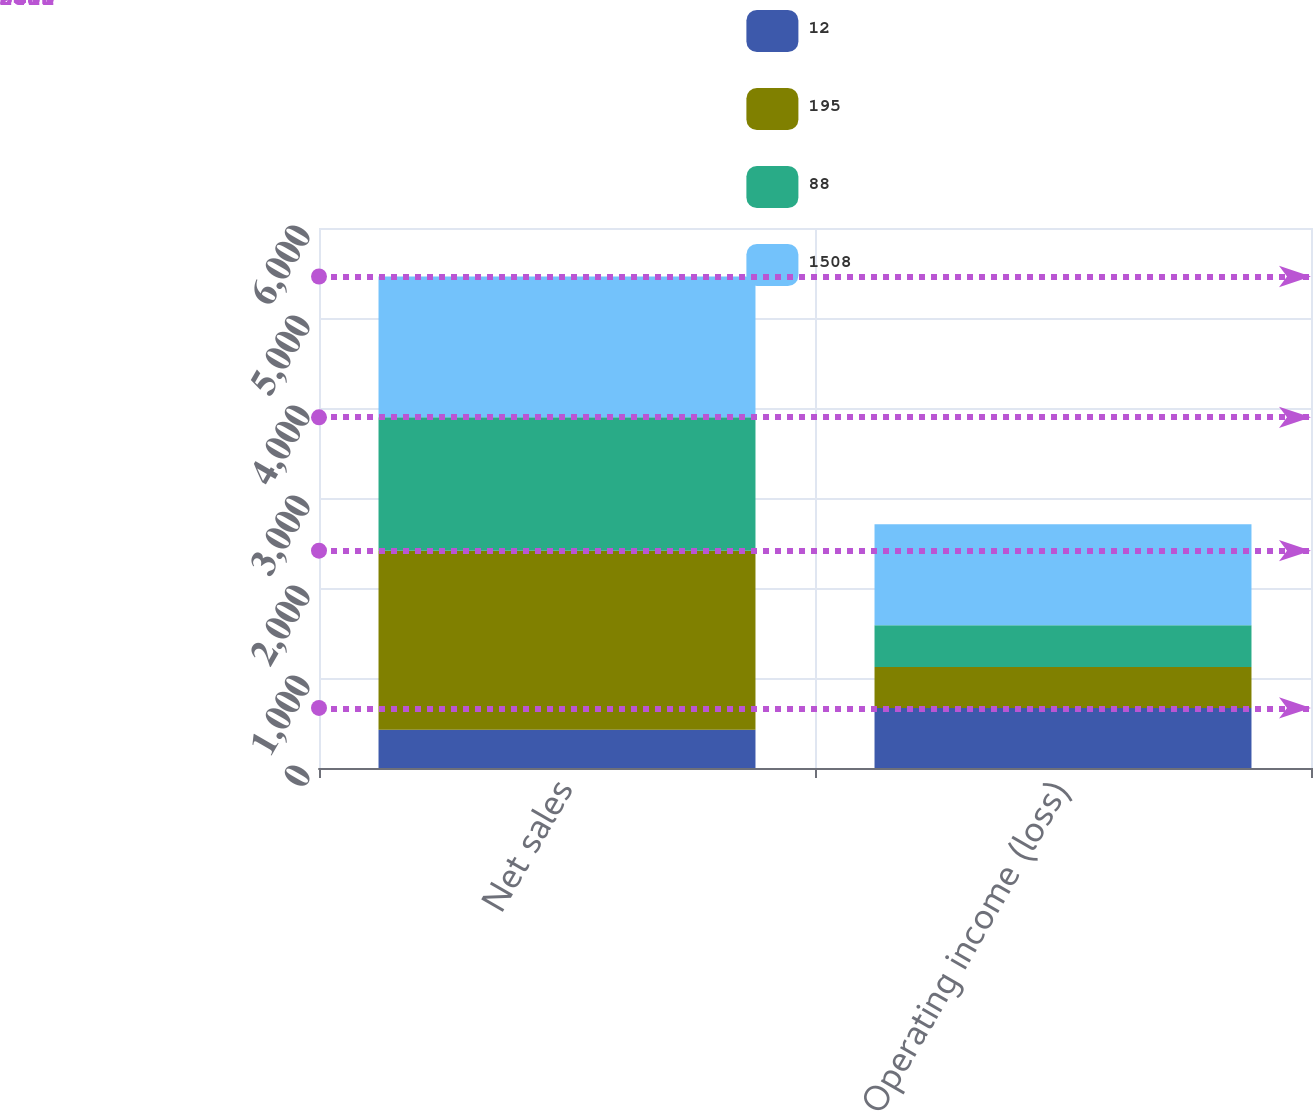Convert chart to OTSL. <chart><loc_0><loc_0><loc_500><loc_500><stacked_bar_chart><ecel><fcel>Net sales<fcel>Operating income (loss)<nl><fcel>12<fcel>425<fcel>668<nl><fcel>195<fcel>1990<fcel>453<nl><fcel>88<fcel>1481<fcel>466<nl><fcel>1508<fcel>1565<fcel>1121<nl></chart> 